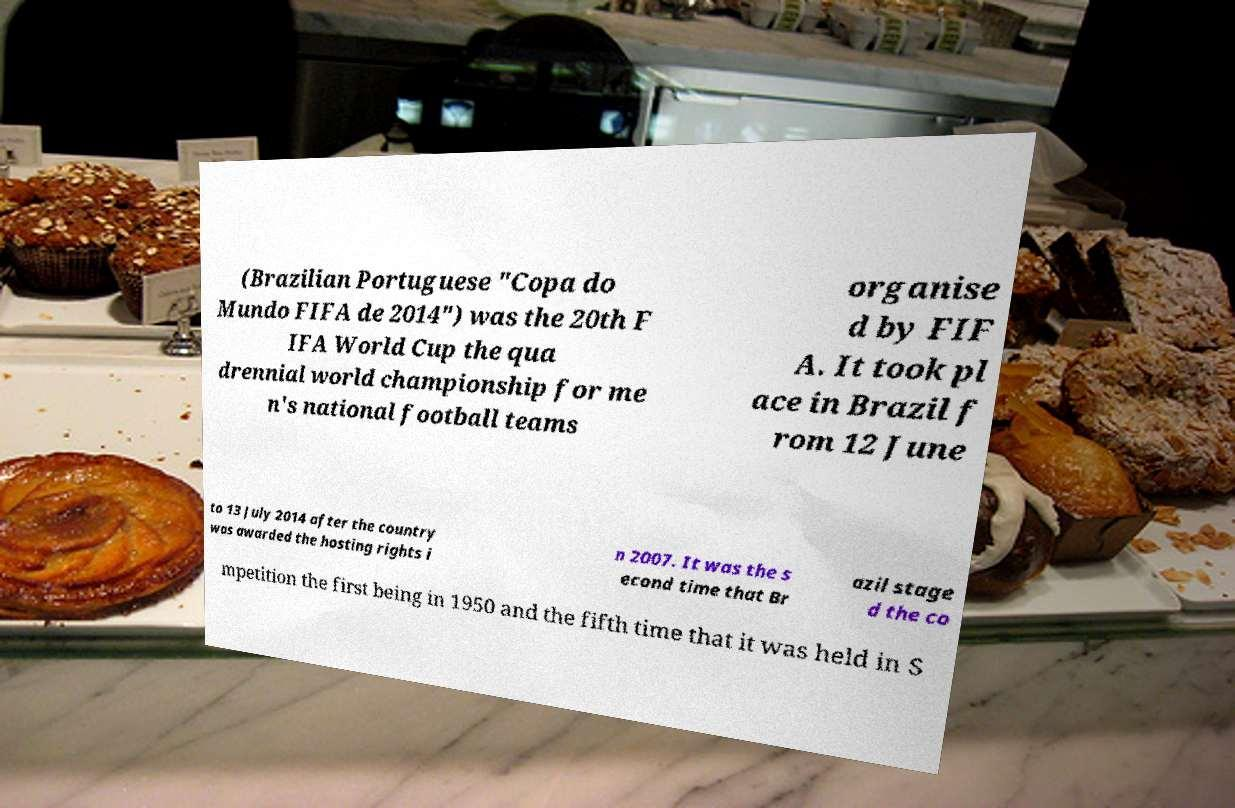I need the written content from this picture converted into text. Can you do that? (Brazilian Portuguese "Copa do Mundo FIFA de 2014") was the 20th F IFA World Cup the qua drennial world championship for me n's national football teams organise d by FIF A. It took pl ace in Brazil f rom 12 June to 13 July 2014 after the country was awarded the hosting rights i n 2007. It was the s econd time that Br azil stage d the co mpetition the first being in 1950 and the fifth time that it was held in S 